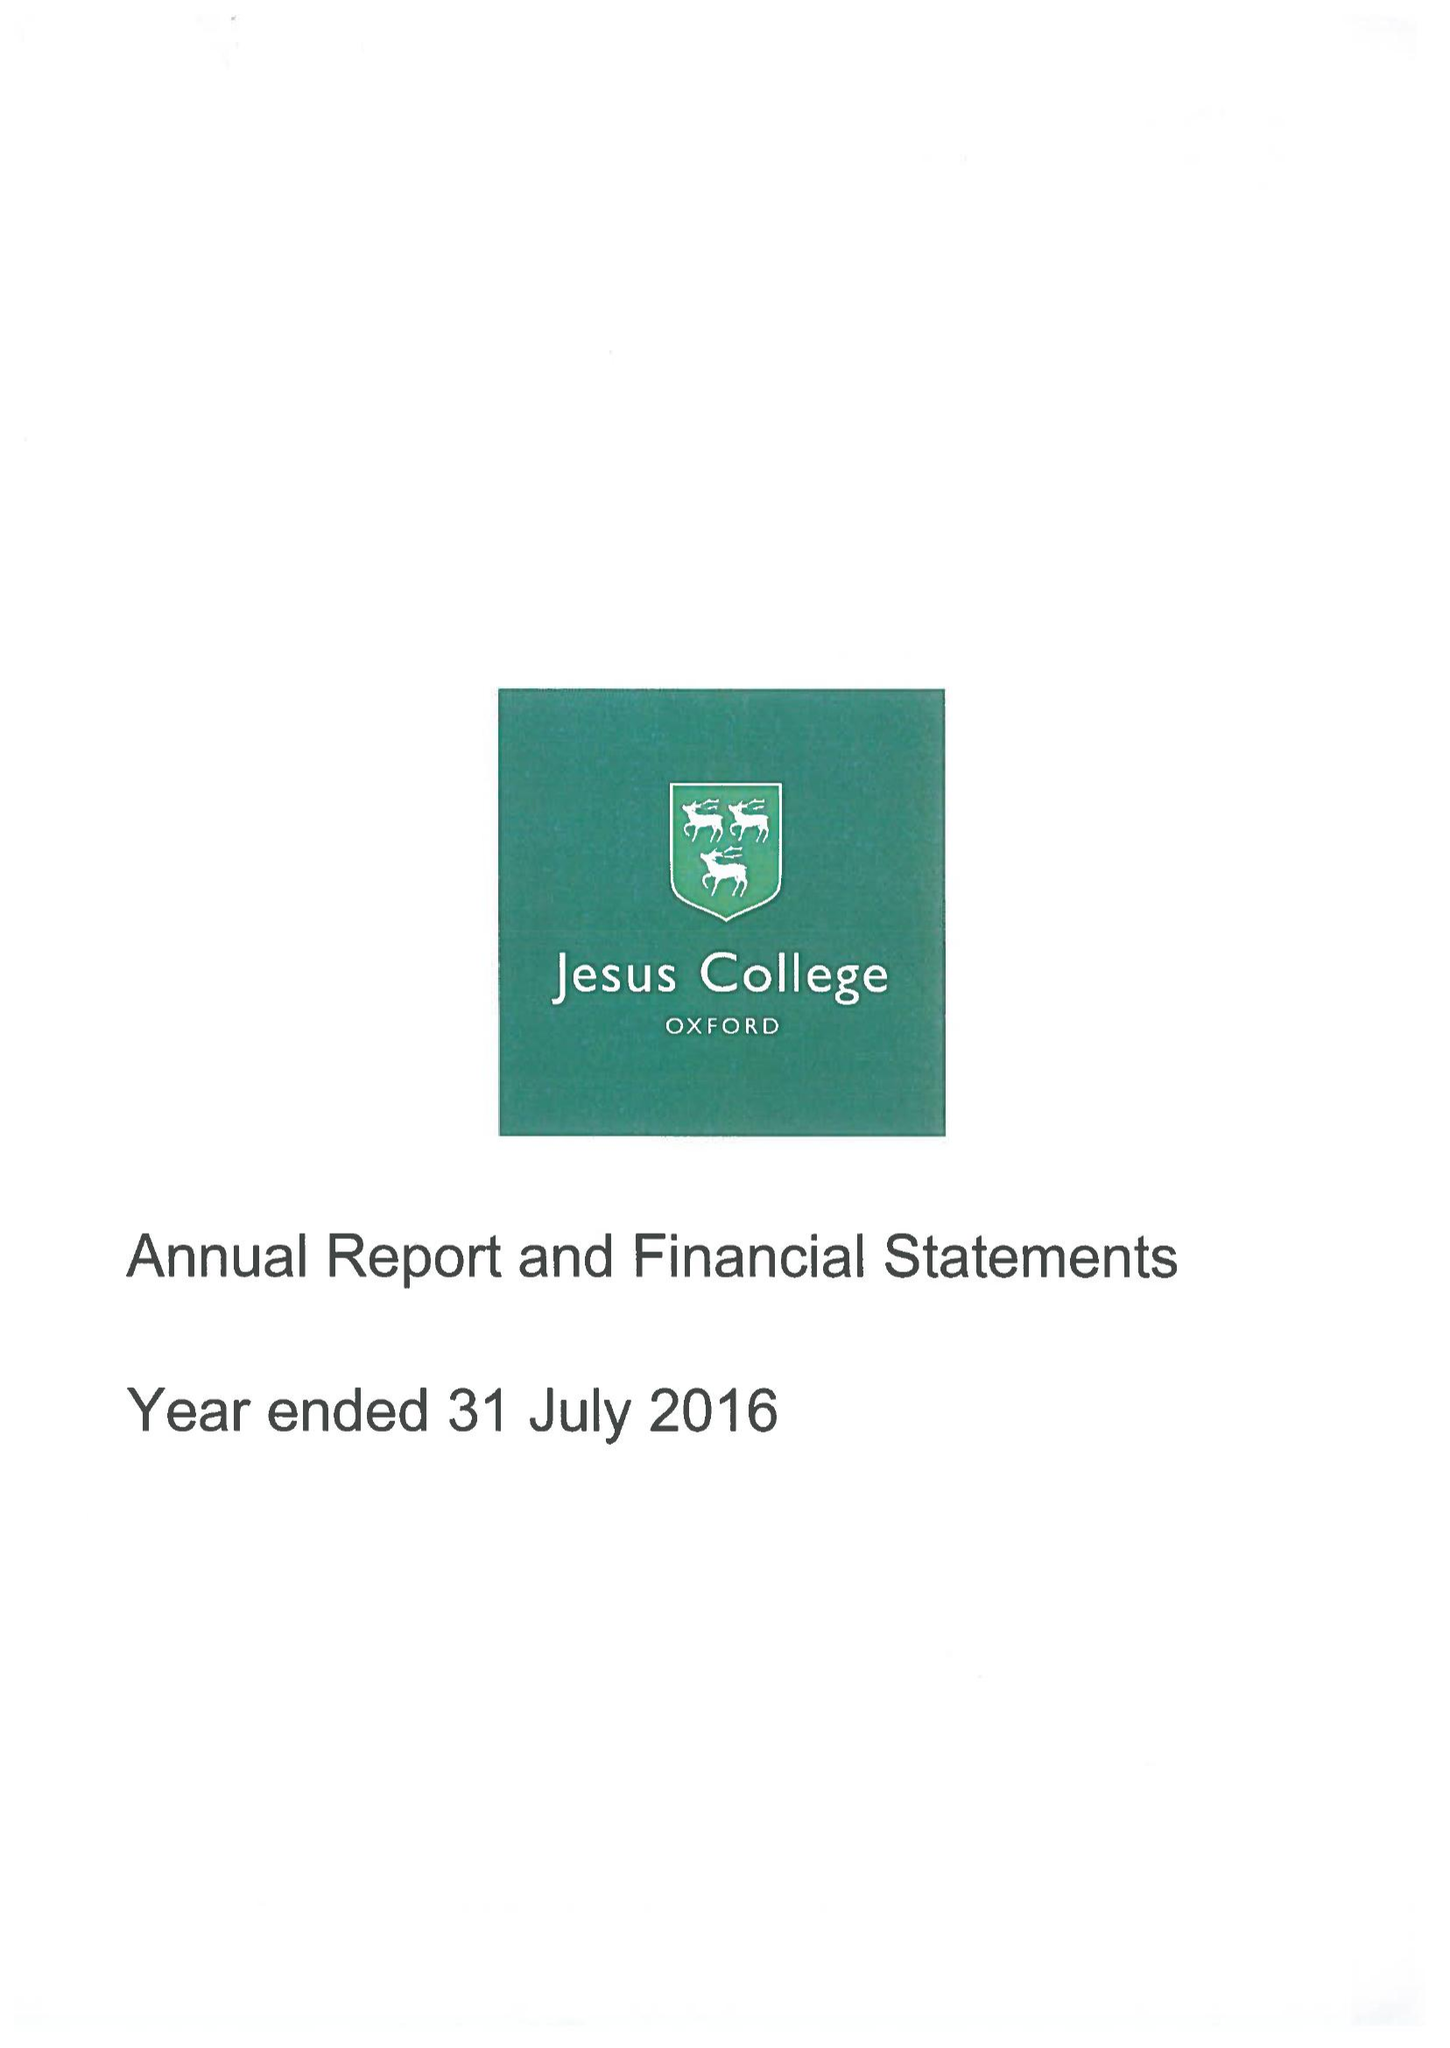What is the value for the address__street_line?
Answer the question using a single word or phrase. TURL STREET 